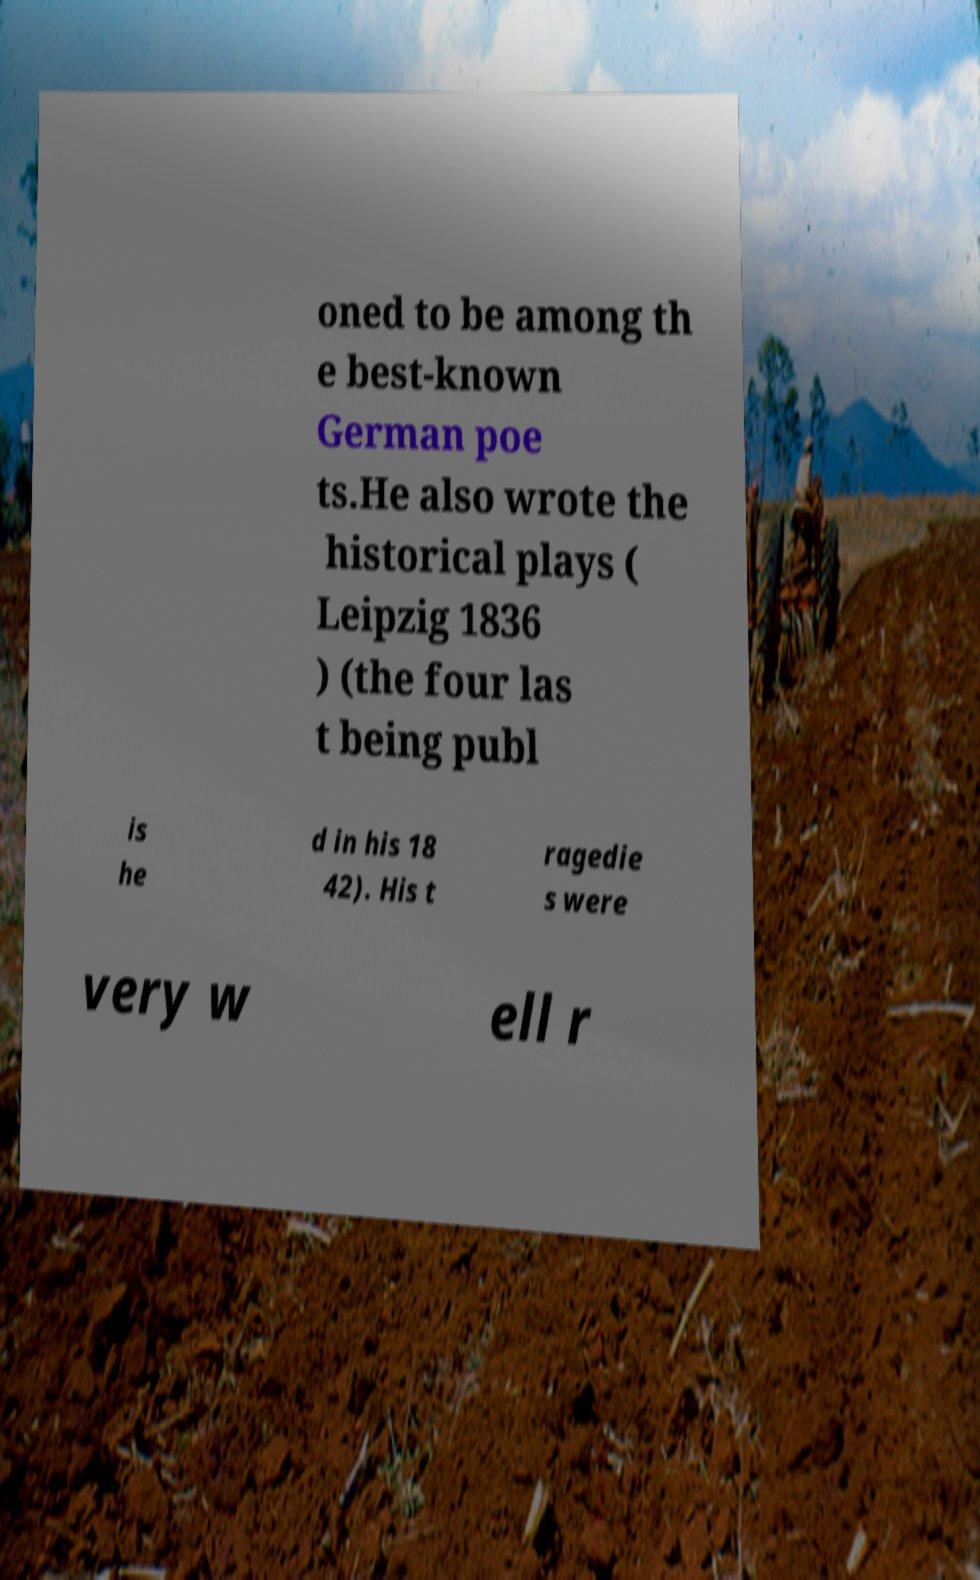Could you extract and type out the text from this image? oned to be among th e best-known German poe ts.He also wrote the historical plays ( Leipzig 1836 ) (the four las t being publ is he d in his 18 42). His t ragedie s were very w ell r 